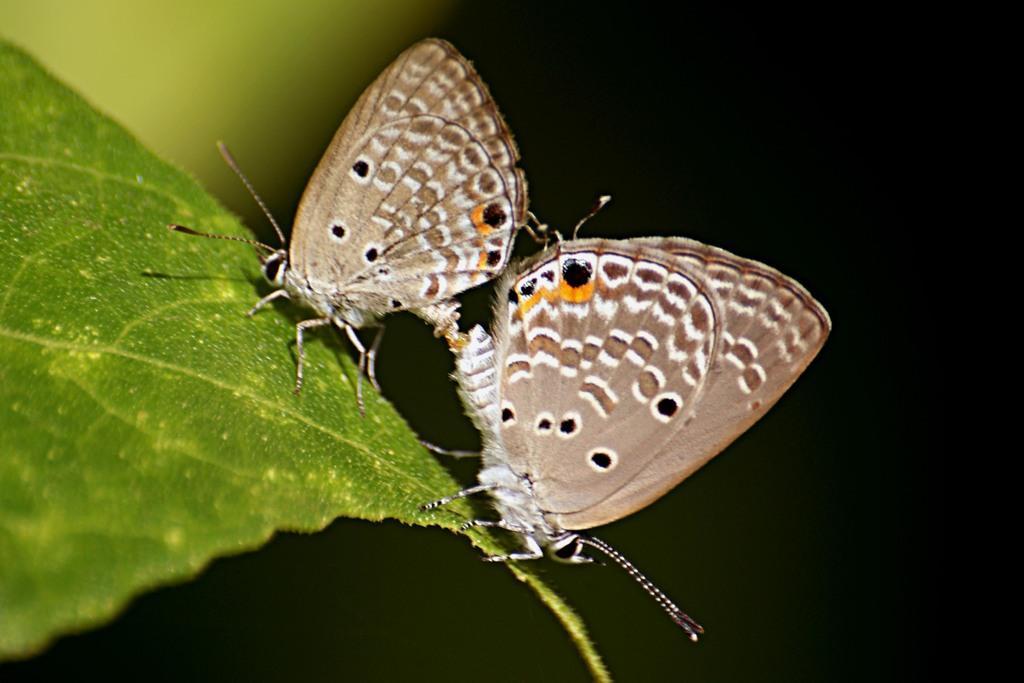How would you summarize this image in a sentence or two? In this image I see 2 butterflies which are of white, brown, orange and black in color and they are on the green leaf and I see that it is dark in the background. 